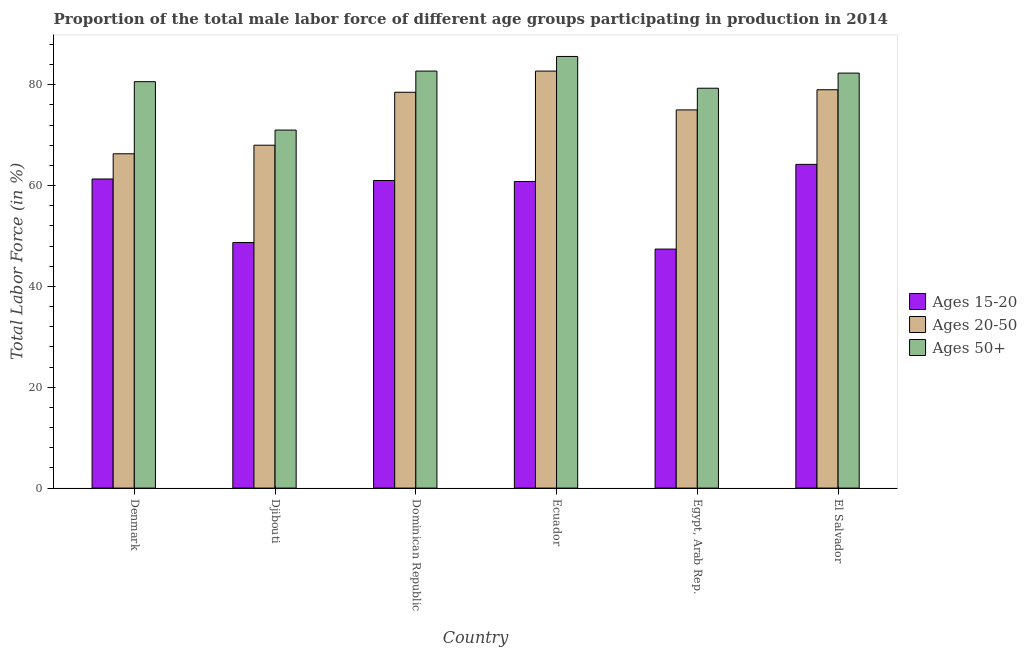How many different coloured bars are there?
Offer a terse response. 3. How many groups of bars are there?
Keep it short and to the point. 6. Are the number of bars per tick equal to the number of legend labels?
Offer a terse response. Yes. How many bars are there on the 4th tick from the right?
Offer a terse response. 3. What is the label of the 5th group of bars from the left?
Your answer should be compact. Egypt, Arab Rep. In how many cases, is the number of bars for a given country not equal to the number of legend labels?
Your answer should be compact. 0. What is the percentage of male labor force within the age group 15-20 in Dominican Republic?
Your answer should be very brief. 61. Across all countries, what is the maximum percentage of male labor force within the age group 20-50?
Your response must be concise. 82.7. In which country was the percentage of male labor force above age 50 maximum?
Provide a succinct answer. Ecuador. What is the total percentage of male labor force within the age group 20-50 in the graph?
Make the answer very short. 449.5. What is the difference between the percentage of male labor force within the age group 20-50 in Dominican Republic and that in Egypt, Arab Rep.?
Give a very brief answer. 3.5. What is the difference between the percentage of male labor force within the age group 15-20 in El Salvador and the percentage of male labor force within the age group 20-50 in Dominican Republic?
Your answer should be compact. -14.3. What is the average percentage of male labor force above age 50 per country?
Your answer should be very brief. 80.25. What is the ratio of the percentage of male labor force above age 50 in Denmark to that in Dominican Republic?
Provide a short and direct response. 0.97. What is the difference between the highest and the second highest percentage of male labor force within the age group 20-50?
Keep it short and to the point. 3.7. What is the difference between the highest and the lowest percentage of male labor force above age 50?
Your response must be concise. 14.6. What does the 2nd bar from the left in Dominican Republic represents?
Your answer should be compact. Ages 20-50. What does the 3rd bar from the right in El Salvador represents?
Make the answer very short. Ages 15-20. Is it the case that in every country, the sum of the percentage of male labor force within the age group 15-20 and percentage of male labor force within the age group 20-50 is greater than the percentage of male labor force above age 50?
Offer a very short reply. Yes. How many countries are there in the graph?
Provide a succinct answer. 6. What is the difference between two consecutive major ticks on the Y-axis?
Ensure brevity in your answer.  20. Does the graph contain grids?
Make the answer very short. No. Where does the legend appear in the graph?
Provide a succinct answer. Center right. How many legend labels are there?
Make the answer very short. 3. How are the legend labels stacked?
Your answer should be compact. Vertical. What is the title of the graph?
Give a very brief answer. Proportion of the total male labor force of different age groups participating in production in 2014. What is the label or title of the X-axis?
Your answer should be compact. Country. What is the Total Labor Force (in %) in Ages 15-20 in Denmark?
Ensure brevity in your answer.  61.3. What is the Total Labor Force (in %) of Ages 20-50 in Denmark?
Provide a succinct answer. 66.3. What is the Total Labor Force (in %) of Ages 50+ in Denmark?
Provide a succinct answer. 80.6. What is the Total Labor Force (in %) in Ages 15-20 in Djibouti?
Provide a succinct answer. 48.7. What is the Total Labor Force (in %) in Ages 20-50 in Djibouti?
Offer a terse response. 68. What is the Total Labor Force (in %) of Ages 50+ in Djibouti?
Your answer should be very brief. 71. What is the Total Labor Force (in %) of Ages 20-50 in Dominican Republic?
Offer a terse response. 78.5. What is the Total Labor Force (in %) in Ages 50+ in Dominican Republic?
Give a very brief answer. 82.7. What is the Total Labor Force (in %) in Ages 15-20 in Ecuador?
Your answer should be compact. 60.8. What is the Total Labor Force (in %) of Ages 20-50 in Ecuador?
Keep it short and to the point. 82.7. What is the Total Labor Force (in %) in Ages 50+ in Ecuador?
Your answer should be very brief. 85.6. What is the Total Labor Force (in %) of Ages 15-20 in Egypt, Arab Rep.?
Provide a succinct answer. 47.4. What is the Total Labor Force (in %) in Ages 50+ in Egypt, Arab Rep.?
Your response must be concise. 79.3. What is the Total Labor Force (in %) in Ages 15-20 in El Salvador?
Keep it short and to the point. 64.2. What is the Total Labor Force (in %) of Ages 20-50 in El Salvador?
Your answer should be very brief. 79. What is the Total Labor Force (in %) in Ages 50+ in El Salvador?
Offer a terse response. 82.3. Across all countries, what is the maximum Total Labor Force (in %) in Ages 15-20?
Make the answer very short. 64.2. Across all countries, what is the maximum Total Labor Force (in %) in Ages 20-50?
Your answer should be compact. 82.7. Across all countries, what is the maximum Total Labor Force (in %) of Ages 50+?
Give a very brief answer. 85.6. Across all countries, what is the minimum Total Labor Force (in %) in Ages 15-20?
Your answer should be very brief. 47.4. Across all countries, what is the minimum Total Labor Force (in %) in Ages 20-50?
Provide a short and direct response. 66.3. What is the total Total Labor Force (in %) of Ages 15-20 in the graph?
Give a very brief answer. 343.4. What is the total Total Labor Force (in %) in Ages 20-50 in the graph?
Keep it short and to the point. 449.5. What is the total Total Labor Force (in %) in Ages 50+ in the graph?
Your response must be concise. 481.5. What is the difference between the Total Labor Force (in %) in Ages 15-20 in Denmark and that in Djibouti?
Your answer should be compact. 12.6. What is the difference between the Total Labor Force (in %) of Ages 20-50 in Denmark and that in Djibouti?
Your answer should be very brief. -1.7. What is the difference between the Total Labor Force (in %) in Ages 50+ in Denmark and that in Djibouti?
Ensure brevity in your answer.  9.6. What is the difference between the Total Labor Force (in %) of Ages 20-50 in Denmark and that in Dominican Republic?
Provide a short and direct response. -12.2. What is the difference between the Total Labor Force (in %) of Ages 50+ in Denmark and that in Dominican Republic?
Your response must be concise. -2.1. What is the difference between the Total Labor Force (in %) of Ages 15-20 in Denmark and that in Ecuador?
Provide a succinct answer. 0.5. What is the difference between the Total Labor Force (in %) of Ages 20-50 in Denmark and that in Ecuador?
Offer a very short reply. -16.4. What is the difference between the Total Labor Force (in %) of Ages 50+ in Denmark and that in Ecuador?
Provide a succinct answer. -5. What is the difference between the Total Labor Force (in %) of Ages 15-20 in Denmark and that in Egypt, Arab Rep.?
Your response must be concise. 13.9. What is the difference between the Total Labor Force (in %) in Ages 20-50 in Denmark and that in Egypt, Arab Rep.?
Offer a terse response. -8.7. What is the difference between the Total Labor Force (in %) of Ages 50+ in Denmark and that in El Salvador?
Offer a very short reply. -1.7. What is the difference between the Total Labor Force (in %) of Ages 15-20 in Djibouti and that in Ecuador?
Give a very brief answer. -12.1. What is the difference between the Total Labor Force (in %) in Ages 20-50 in Djibouti and that in Ecuador?
Your answer should be compact. -14.7. What is the difference between the Total Labor Force (in %) in Ages 50+ in Djibouti and that in Ecuador?
Your answer should be very brief. -14.6. What is the difference between the Total Labor Force (in %) in Ages 50+ in Djibouti and that in Egypt, Arab Rep.?
Give a very brief answer. -8.3. What is the difference between the Total Labor Force (in %) of Ages 15-20 in Djibouti and that in El Salvador?
Provide a succinct answer. -15.5. What is the difference between the Total Labor Force (in %) in Ages 20-50 in Dominican Republic and that in Ecuador?
Your response must be concise. -4.2. What is the difference between the Total Labor Force (in %) in Ages 50+ in Dominican Republic and that in Ecuador?
Make the answer very short. -2.9. What is the difference between the Total Labor Force (in %) in Ages 15-20 in Dominican Republic and that in El Salvador?
Your answer should be very brief. -3.2. What is the difference between the Total Labor Force (in %) of Ages 20-50 in Dominican Republic and that in El Salvador?
Offer a very short reply. -0.5. What is the difference between the Total Labor Force (in %) in Ages 15-20 in Ecuador and that in Egypt, Arab Rep.?
Offer a very short reply. 13.4. What is the difference between the Total Labor Force (in %) of Ages 20-50 in Ecuador and that in Egypt, Arab Rep.?
Provide a succinct answer. 7.7. What is the difference between the Total Labor Force (in %) of Ages 50+ in Ecuador and that in Egypt, Arab Rep.?
Your response must be concise. 6.3. What is the difference between the Total Labor Force (in %) of Ages 15-20 in Ecuador and that in El Salvador?
Provide a short and direct response. -3.4. What is the difference between the Total Labor Force (in %) of Ages 20-50 in Ecuador and that in El Salvador?
Your response must be concise. 3.7. What is the difference between the Total Labor Force (in %) of Ages 50+ in Ecuador and that in El Salvador?
Ensure brevity in your answer.  3.3. What is the difference between the Total Labor Force (in %) of Ages 15-20 in Egypt, Arab Rep. and that in El Salvador?
Your response must be concise. -16.8. What is the difference between the Total Labor Force (in %) of Ages 50+ in Egypt, Arab Rep. and that in El Salvador?
Your answer should be compact. -3. What is the difference between the Total Labor Force (in %) in Ages 15-20 in Denmark and the Total Labor Force (in %) in Ages 20-50 in Djibouti?
Your answer should be compact. -6.7. What is the difference between the Total Labor Force (in %) in Ages 15-20 in Denmark and the Total Labor Force (in %) in Ages 50+ in Djibouti?
Provide a succinct answer. -9.7. What is the difference between the Total Labor Force (in %) of Ages 15-20 in Denmark and the Total Labor Force (in %) of Ages 20-50 in Dominican Republic?
Your answer should be very brief. -17.2. What is the difference between the Total Labor Force (in %) of Ages 15-20 in Denmark and the Total Labor Force (in %) of Ages 50+ in Dominican Republic?
Your response must be concise. -21.4. What is the difference between the Total Labor Force (in %) of Ages 20-50 in Denmark and the Total Labor Force (in %) of Ages 50+ in Dominican Republic?
Keep it short and to the point. -16.4. What is the difference between the Total Labor Force (in %) of Ages 15-20 in Denmark and the Total Labor Force (in %) of Ages 20-50 in Ecuador?
Keep it short and to the point. -21.4. What is the difference between the Total Labor Force (in %) in Ages 15-20 in Denmark and the Total Labor Force (in %) in Ages 50+ in Ecuador?
Offer a very short reply. -24.3. What is the difference between the Total Labor Force (in %) of Ages 20-50 in Denmark and the Total Labor Force (in %) of Ages 50+ in Ecuador?
Provide a short and direct response. -19.3. What is the difference between the Total Labor Force (in %) in Ages 15-20 in Denmark and the Total Labor Force (in %) in Ages 20-50 in Egypt, Arab Rep.?
Provide a succinct answer. -13.7. What is the difference between the Total Labor Force (in %) in Ages 20-50 in Denmark and the Total Labor Force (in %) in Ages 50+ in Egypt, Arab Rep.?
Keep it short and to the point. -13. What is the difference between the Total Labor Force (in %) in Ages 15-20 in Denmark and the Total Labor Force (in %) in Ages 20-50 in El Salvador?
Your answer should be compact. -17.7. What is the difference between the Total Labor Force (in %) in Ages 15-20 in Denmark and the Total Labor Force (in %) in Ages 50+ in El Salvador?
Your answer should be compact. -21. What is the difference between the Total Labor Force (in %) in Ages 15-20 in Djibouti and the Total Labor Force (in %) in Ages 20-50 in Dominican Republic?
Ensure brevity in your answer.  -29.8. What is the difference between the Total Labor Force (in %) of Ages 15-20 in Djibouti and the Total Labor Force (in %) of Ages 50+ in Dominican Republic?
Offer a terse response. -34. What is the difference between the Total Labor Force (in %) of Ages 20-50 in Djibouti and the Total Labor Force (in %) of Ages 50+ in Dominican Republic?
Offer a terse response. -14.7. What is the difference between the Total Labor Force (in %) in Ages 15-20 in Djibouti and the Total Labor Force (in %) in Ages 20-50 in Ecuador?
Your answer should be compact. -34. What is the difference between the Total Labor Force (in %) of Ages 15-20 in Djibouti and the Total Labor Force (in %) of Ages 50+ in Ecuador?
Your answer should be very brief. -36.9. What is the difference between the Total Labor Force (in %) in Ages 20-50 in Djibouti and the Total Labor Force (in %) in Ages 50+ in Ecuador?
Your answer should be compact. -17.6. What is the difference between the Total Labor Force (in %) of Ages 15-20 in Djibouti and the Total Labor Force (in %) of Ages 20-50 in Egypt, Arab Rep.?
Ensure brevity in your answer.  -26.3. What is the difference between the Total Labor Force (in %) in Ages 15-20 in Djibouti and the Total Labor Force (in %) in Ages 50+ in Egypt, Arab Rep.?
Provide a short and direct response. -30.6. What is the difference between the Total Labor Force (in %) of Ages 20-50 in Djibouti and the Total Labor Force (in %) of Ages 50+ in Egypt, Arab Rep.?
Provide a short and direct response. -11.3. What is the difference between the Total Labor Force (in %) in Ages 15-20 in Djibouti and the Total Labor Force (in %) in Ages 20-50 in El Salvador?
Offer a very short reply. -30.3. What is the difference between the Total Labor Force (in %) of Ages 15-20 in Djibouti and the Total Labor Force (in %) of Ages 50+ in El Salvador?
Ensure brevity in your answer.  -33.6. What is the difference between the Total Labor Force (in %) in Ages 20-50 in Djibouti and the Total Labor Force (in %) in Ages 50+ in El Salvador?
Provide a succinct answer. -14.3. What is the difference between the Total Labor Force (in %) in Ages 15-20 in Dominican Republic and the Total Labor Force (in %) in Ages 20-50 in Ecuador?
Make the answer very short. -21.7. What is the difference between the Total Labor Force (in %) of Ages 15-20 in Dominican Republic and the Total Labor Force (in %) of Ages 50+ in Ecuador?
Offer a very short reply. -24.6. What is the difference between the Total Labor Force (in %) of Ages 15-20 in Dominican Republic and the Total Labor Force (in %) of Ages 50+ in Egypt, Arab Rep.?
Give a very brief answer. -18.3. What is the difference between the Total Labor Force (in %) of Ages 15-20 in Dominican Republic and the Total Labor Force (in %) of Ages 50+ in El Salvador?
Offer a terse response. -21.3. What is the difference between the Total Labor Force (in %) of Ages 15-20 in Ecuador and the Total Labor Force (in %) of Ages 50+ in Egypt, Arab Rep.?
Your response must be concise. -18.5. What is the difference between the Total Labor Force (in %) of Ages 20-50 in Ecuador and the Total Labor Force (in %) of Ages 50+ in Egypt, Arab Rep.?
Offer a very short reply. 3.4. What is the difference between the Total Labor Force (in %) of Ages 15-20 in Ecuador and the Total Labor Force (in %) of Ages 20-50 in El Salvador?
Give a very brief answer. -18.2. What is the difference between the Total Labor Force (in %) of Ages 15-20 in Ecuador and the Total Labor Force (in %) of Ages 50+ in El Salvador?
Provide a short and direct response. -21.5. What is the difference between the Total Labor Force (in %) of Ages 20-50 in Ecuador and the Total Labor Force (in %) of Ages 50+ in El Salvador?
Keep it short and to the point. 0.4. What is the difference between the Total Labor Force (in %) of Ages 15-20 in Egypt, Arab Rep. and the Total Labor Force (in %) of Ages 20-50 in El Salvador?
Offer a terse response. -31.6. What is the difference between the Total Labor Force (in %) of Ages 15-20 in Egypt, Arab Rep. and the Total Labor Force (in %) of Ages 50+ in El Salvador?
Your answer should be compact. -34.9. What is the difference between the Total Labor Force (in %) in Ages 20-50 in Egypt, Arab Rep. and the Total Labor Force (in %) in Ages 50+ in El Salvador?
Your answer should be very brief. -7.3. What is the average Total Labor Force (in %) of Ages 15-20 per country?
Your answer should be very brief. 57.23. What is the average Total Labor Force (in %) in Ages 20-50 per country?
Your answer should be very brief. 74.92. What is the average Total Labor Force (in %) in Ages 50+ per country?
Offer a terse response. 80.25. What is the difference between the Total Labor Force (in %) in Ages 15-20 and Total Labor Force (in %) in Ages 20-50 in Denmark?
Ensure brevity in your answer.  -5. What is the difference between the Total Labor Force (in %) of Ages 15-20 and Total Labor Force (in %) of Ages 50+ in Denmark?
Provide a short and direct response. -19.3. What is the difference between the Total Labor Force (in %) in Ages 20-50 and Total Labor Force (in %) in Ages 50+ in Denmark?
Offer a very short reply. -14.3. What is the difference between the Total Labor Force (in %) of Ages 15-20 and Total Labor Force (in %) of Ages 20-50 in Djibouti?
Give a very brief answer. -19.3. What is the difference between the Total Labor Force (in %) in Ages 15-20 and Total Labor Force (in %) in Ages 50+ in Djibouti?
Offer a very short reply. -22.3. What is the difference between the Total Labor Force (in %) in Ages 15-20 and Total Labor Force (in %) in Ages 20-50 in Dominican Republic?
Your answer should be compact. -17.5. What is the difference between the Total Labor Force (in %) of Ages 15-20 and Total Labor Force (in %) of Ages 50+ in Dominican Republic?
Ensure brevity in your answer.  -21.7. What is the difference between the Total Labor Force (in %) of Ages 20-50 and Total Labor Force (in %) of Ages 50+ in Dominican Republic?
Provide a short and direct response. -4.2. What is the difference between the Total Labor Force (in %) of Ages 15-20 and Total Labor Force (in %) of Ages 20-50 in Ecuador?
Your response must be concise. -21.9. What is the difference between the Total Labor Force (in %) in Ages 15-20 and Total Labor Force (in %) in Ages 50+ in Ecuador?
Your answer should be compact. -24.8. What is the difference between the Total Labor Force (in %) in Ages 15-20 and Total Labor Force (in %) in Ages 20-50 in Egypt, Arab Rep.?
Provide a succinct answer. -27.6. What is the difference between the Total Labor Force (in %) in Ages 15-20 and Total Labor Force (in %) in Ages 50+ in Egypt, Arab Rep.?
Your answer should be very brief. -31.9. What is the difference between the Total Labor Force (in %) of Ages 20-50 and Total Labor Force (in %) of Ages 50+ in Egypt, Arab Rep.?
Ensure brevity in your answer.  -4.3. What is the difference between the Total Labor Force (in %) of Ages 15-20 and Total Labor Force (in %) of Ages 20-50 in El Salvador?
Make the answer very short. -14.8. What is the difference between the Total Labor Force (in %) in Ages 15-20 and Total Labor Force (in %) in Ages 50+ in El Salvador?
Ensure brevity in your answer.  -18.1. What is the difference between the Total Labor Force (in %) of Ages 20-50 and Total Labor Force (in %) of Ages 50+ in El Salvador?
Your response must be concise. -3.3. What is the ratio of the Total Labor Force (in %) of Ages 15-20 in Denmark to that in Djibouti?
Your answer should be compact. 1.26. What is the ratio of the Total Labor Force (in %) of Ages 50+ in Denmark to that in Djibouti?
Your answer should be compact. 1.14. What is the ratio of the Total Labor Force (in %) in Ages 15-20 in Denmark to that in Dominican Republic?
Keep it short and to the point. 1. What is the ratio of the Total Labor Force (in %) of Ages 20-50 in Denmark to that in Dominican Republic?
Provide a succinct answer. 0.84. What is the ratio of the Total Labor Force (in %) of Ages 50+ in Denmark to that in Dominican Republic?
Make the answer very short. 0.97. What is the ratio of the Total Labor Force (in %) of Ages 15-20 in Denmark to that in Ecuador?
Make the answer very short. 1.01. What is the ratio of the Total Labor Force (in %) of Ages 20-50 in Denmark to that in Ecuador?
Provide a succinct answer. 0.8. What is the ratio of the Total Labor Force (in %) of Ages 50+ in Denmark to that in Ecuador?
Offer a very short reply. 0.94. What is the ratio of the Total Labor Force (in %) in Ages 15-20 in Denmark to that in Egypt, Arab Rep.?
Ensure brevity in your answer.  1.29. What is the ratio of the Total Labor Force (in %) in Ages 20-50 in Denmark to that in Egypt, Arab Rep.?
Give a very brief answer. 0.88. What is the ratio of the Total Labor Force (in %) in Ages 50+ in Denmark to that in Egypt, Arab Rep.?
Offer a very short reply. 1.02. What is the ratio of the Total Labor Force (in %) in Ages 15-20 in Denmark to that in El Salvador?
Your answer should be very brief. 0.95. What is the ratio of the Total Labor Force (in %) of Ages 20-50 in Denmark to that in El Salvador?
Your response must be concise. 0.84. What is the ratio of the Total Labor Force (in %) in Ages 50+ in Denmark to that in El Salvador?
Provide a succinct answer. 0.98. What is the ratio of the Total Labor Force (in %) in Ages 15-20 in Djibouti to that in Dominican Republic?
Offer a very short reply. 0.8. What is the ratio of the Total Labor Force (in %) of Ages 20-50 in Djibouti to that in Dominican Republic?
Ensure brevity in your answer.  0.87. What is the ratio of the Total Labor Force (in %) in Ages 50+ in Djibouti to that in Dominican Republic?
Your response must be concise. 0.86. What is the ratio of the Total Labor Force (in %) in Ages 15-20 in Djibouti to that in Ecuador?
Offer a terse response. 0.8. What is the ratio of the Total Labor Force (in %) in Ages 20-50 in Djibouti to that in Ecuador?
Your answer should be very brief. 0.82. What is the ratio of the Total Labor Force (in %) in Ages 50+ in Djibouti to that in Ecuador?
Give a very brief answer. 0.83. What is the ratio of the Total Labor Force (in %) in Ages 15-20 in Djibouti to that in Egypt, Arab Rep.?
Provide a succinct answer. 1.03. What is the ratio of the Total Labor Force (in %) of Ages 20-50 in Djibouti to that in Egypt, Arab Rep.?
Provide a short and direct response. 0.91. What is the ratio of the Total Labor Force (in %) in Ages 50+ in Djibouti to that in Egypt, Arab Rep.?
Your answer should be compact. 0.9. What is the ratio of the Total Labor Force (in %) in Ages 15-20 in Djibouti to that in El Salvador?
Give a very brief answer. 0.76. What is the ratio of the Total Labor Force (in %) of Ages 20-50 in Djibouti to that in El Salvador?
Provide a succinct answer. 0.86. What is the ratio of the Total Labor Force (in %) of Ages 50+ in Djibouti to that in El Salvador?
Give a very brief answer. 0.86. What is the ratio of the Total Labor Force (in %) of Ages 20-50 in Dominican Republic to that in Ecuador?
Provide a succinct answer. 0.95. What is the ratio of the Total Labor Force (in %) of Ages 50+ in Dominican Republic to that in Ecuador?
Provide a short and direct response. 0.97. What is the ratio of the Total Labor Force (in %) of Ages 15-20 in Dominican Republic to that in Egypt, Arab Rep.?
Offer a terse response. 1.29. What is the ratio of the Total Labor Force (in %) in Ages 20-50 in Dominican Republic to that in Egypt, Arab Rep.?
Your answer should be very brief. 1.05. What is the ratio of the Total Labor Force (in %) in Ages 50+ in Dominican Republic to that in Egypt, Arab Rep.?
Ensure brevity in your answer.  1.04. What is the ratio of the Total Labor Force (in %) in Ages 15-20 in Dominican Republic to that in El Salvador?
Ensure brevity in your answer.  0.95. What is the ratio of the Total Labor Force (in %) of Ages 20-50 in Dominican Republic to that in El Salvador?
Provide a succinct answer. 0.99. What is the ratio of the Total Labor Force (in %) of Ages 50+ in Dominican Republic to that in El Salvador?
Your response must be concise. 1. What is the ratio of the Total Labor Force (in %) in Ages 15-20 in Ecuador to that in Egypt, Arab Rep.?
Your answer should be compact. 1.28. What is the ratio of the Total Labor Force (in %) in Ages 20-50 in Ecuador to that in Egypt, Arab Rep.?
Your answer should be compact. 1.1. What is the ratio of the Total Labor Force (in %) of Ages 50+ in Ecuador to that in Egypt, Arab Rep.?
Offer a terse response. 1.08. What is the ratio of the Total Labor Force (in %) in Ages 15-20 in Ecuador to that in El Salvador?
Your answer should be very brief. 0.95. What is the ratio of the Total Labor Force (in %) of Ages 20-50 in Ecuador to that in El Salvador?
Give a very brief answer. 1.05. What is the ratio of the Total Labor Force (in %) in Ages 50+ in Ecuador to that in El Salvador?
Ensure brevity in your answer.  1.04. What is the ratio of the Total Labor Force (in %) of Ages 15-20 in Egypt, Arab Rep. to that in El Salvador?
Your answer should be compact. 0.74. What is the ratio of the Total Labor Force (in %) of Ages 20-50 in Egypt, Arab Rep. to that in El Salvador?
Ensure brevity in your answer.  0.95. What is the ratio of the Total Labor Force (in %) of Ages 50+ in Egypt, Arab Rep. to that in El Salvador?
Ensure brevity in your answer.  0.96. What is the difference between the highest and the second highest Total Labor Force (in %) of Ages 20-50?
Your response must be concise. 3.7. What is the difference between the highest and the lowest Total Labor Force (in %) of Ages 20-50?
Ensure brevity in your answer.  16.4. 